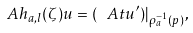Convert formula to latex. <formula><loc_0><loc_0><loc_500><loc_500>\ A h _ { a , l } ( \zeta ) u = ( \ A t u ^ { \prime } ) | _ { \rho _ { a } ^ { - 1 } ( p ) } ,</formula> 